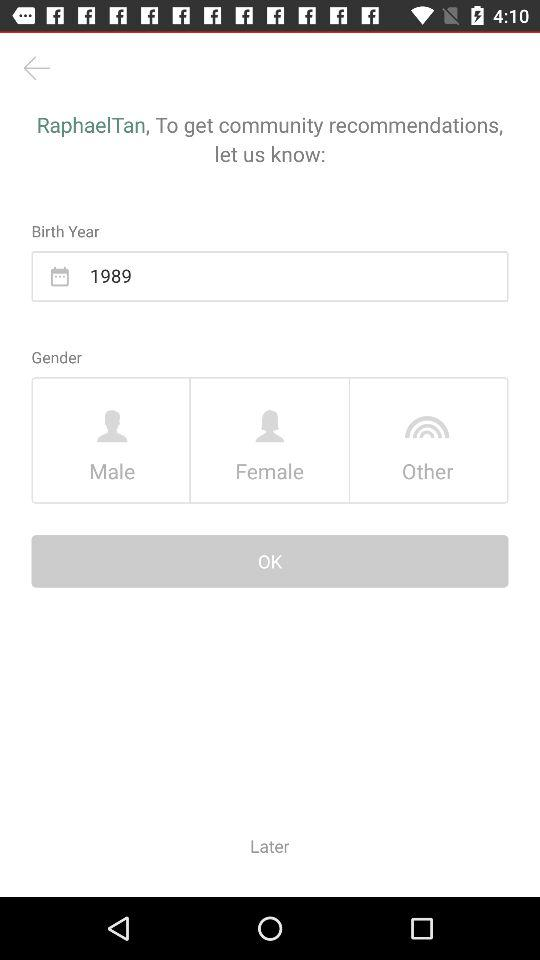What is the given gender option? The given options are "Male", "Female" and "Other". 